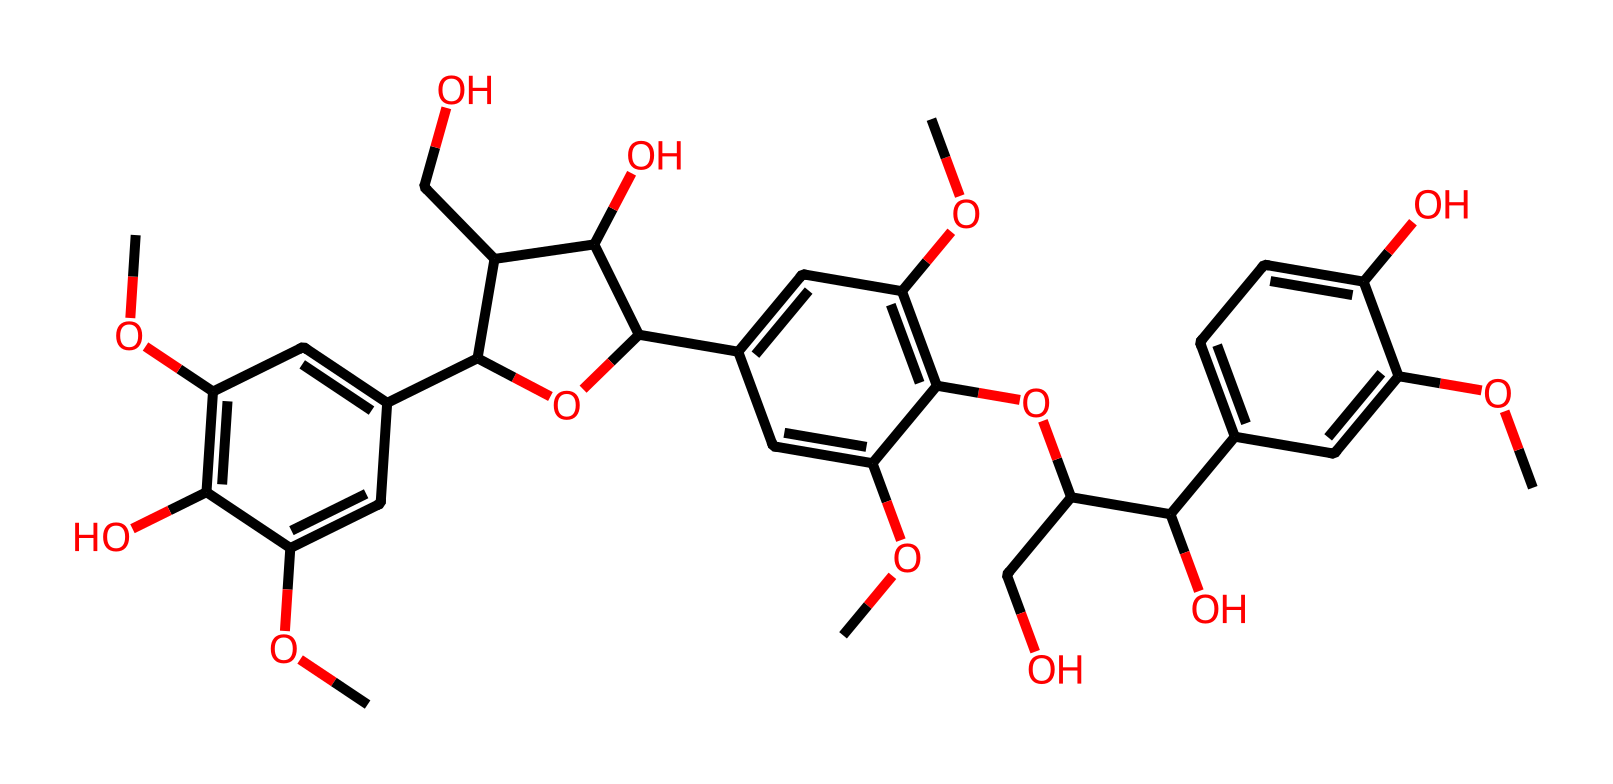What is the molecular formula of lignin represented by this SMILES? To determine the molecular formula, one would need to identify the types and counts of each atom in the structure based on the SMILES representation. Here, you can visually count carbon (C), hydrogen (H), and oxygen (O) atoms, leading to the molecular formula C21H26O10.
Answer: C21H26O10 How many rings are present in this chemical structure? The presence of rings can be assessed by looking for cyclic structures in the chemical representation. In this case, there are three distinct ring structures identified in the compound.
Answer: 3 What is the type of functional groups present in this molecule? By examining the functional groups, we can note hydroxyl (–OH), methoxy (–OCH3), and phenolic groups. These groups define the reactivity and properties of lignin in the structure.
Answer: hydroxyl, methoxy, phenolic Which type of solid is lignin classified as? Based on the information about the structure, lignin is typically classified as an amorphous solid due to its complex and irregular structure without a well-defined crystalline form.
Answer: amorphous What characteristic feature does the presence of multiple –OH groups impart to this structure? The multiple hydroxyl (–OH) groups increase the polarity and hydrogen-bonding capacity of the molecule. This contributes to the solubility and reactivity of lignin in various applications, including in paper production.
Answer: increased polarity Does this chemical structure indicate a high degree of branching? Investigating the arrangement of carbons in the structure reveals that there are numerous branches off the main chains and rings, suggesting a high degree of branching within the lignin structure.
Answer: yes 